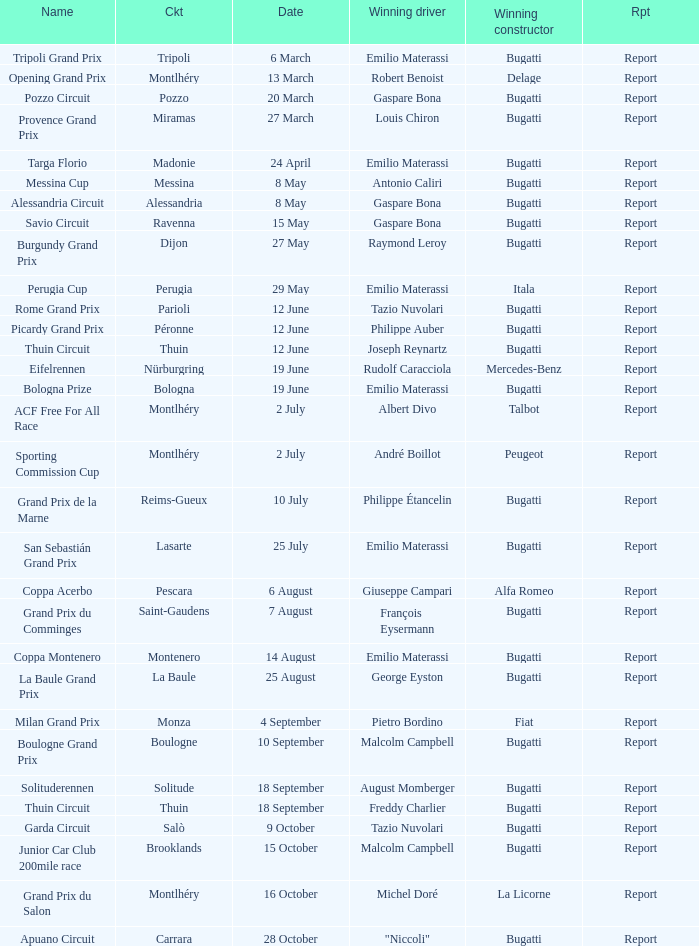Who was the winning constructor at the circuit of parioli? Bugatti. 